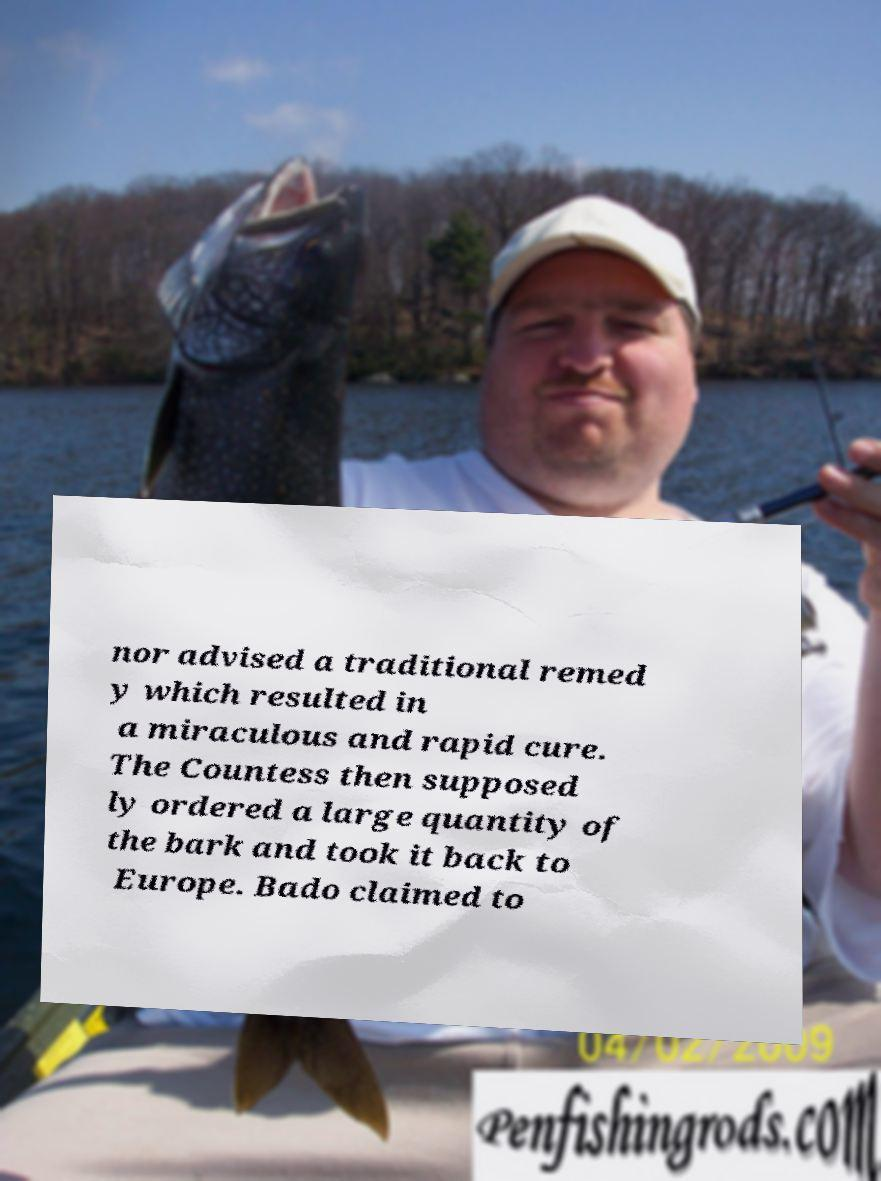I need the written content from this picture converted into text. Can you do that? nor advised a traditional remed y which resulted in a miraculous and rapid cure. The Countess then supposed ly ordered a large quantity of the bark and took it back to Europe. Bado claimed to 